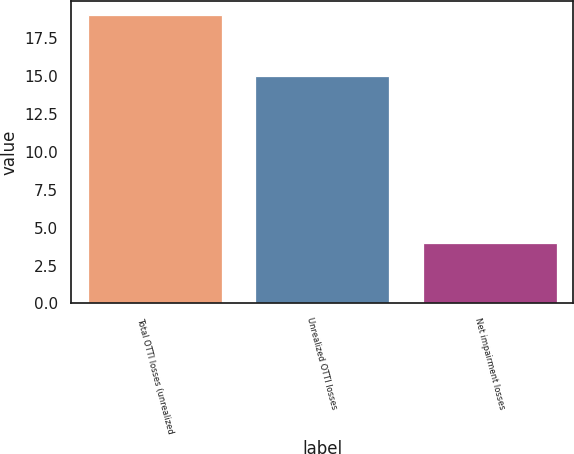Convert chart to OTSL. <chart><loc_0><loc_0><loc_500><loc_500><bar_chart><fcel>Total OTTI losses (unrealized<fcel>Unrealized OTTI losses<fcel>Net impairment losses<nl><fcel>19<fcel>15<fcel>4<nl></chart> 